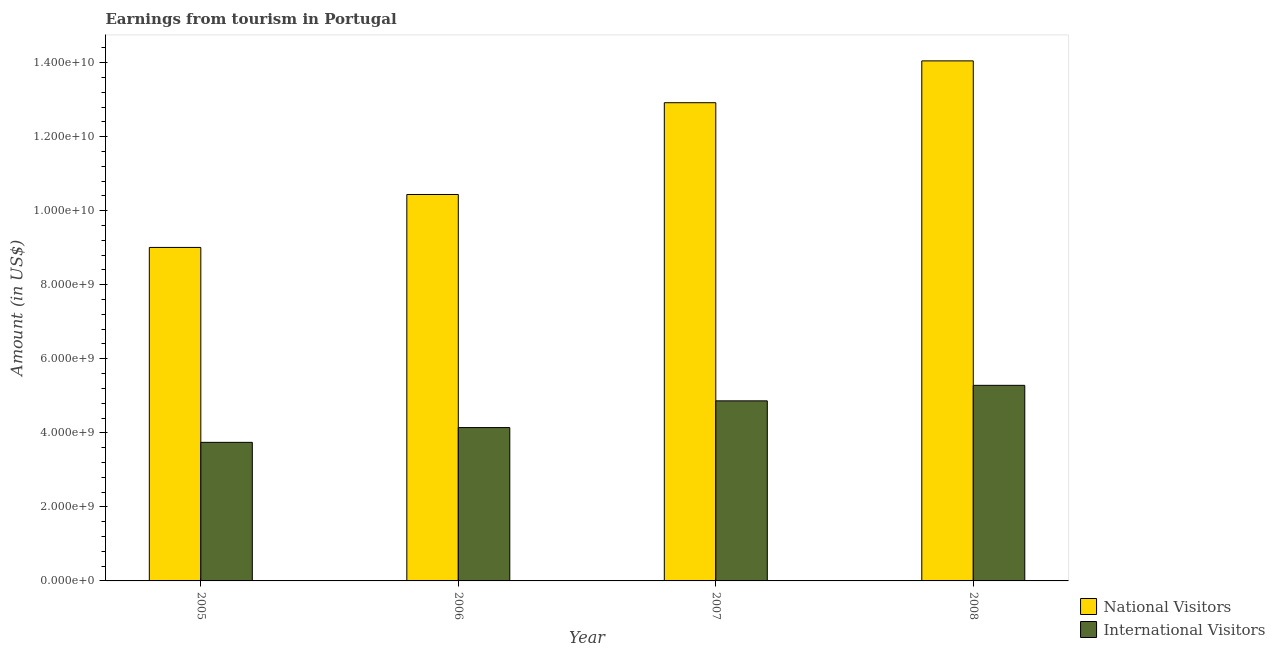How many different coloured bars are there?
Offer a terse response. 2. How many groups of bars are there?
Ensure brevity in your answer.  4. Are the number of bars on each tick of the X-axis equal?
Your answer should be compact. Yes. How many bars are there on the 4th tick from the left?
Your response must be concise. 2. How many bars are there on the 2nd tick from the right?
Make the answer very short. 2. What is the label of the 4th group of bars from the left?
Offer a terse response. 2008. What is the amount earned from national visitors in 2006?
Offer a very short reply. 1.04e+1. Across all years, what is the maximum amount earned from international visitors?
Keep it short and to the point. 5.28e+09. Across all years, what is the minimum amount earned from international visitors?
Make the answer very short. 3.74e+09. In which year was the amount earned from national visitors minimum?
Offer a terse response. 2005. What is the total amount earned from international visitors in the graph?
Your answer should be very brief. 1.80e+1. What is the difference between the amount earned from international visitors in 2006 and that in 2008?
Offer a very short reply. -1.14e+09. What is the difference between the amount earned from international visitors in 2008 and the amount earned from national visitors in 2007?
Provide a short and direct response. 4.19e+08. What is the average amount earned from national visitors per year?
Provide a short and direct response. 1.16e+1. What is the ratio of the amount earned from national visitors in 2007 to that in 2008?
Provide a succinct answer. 0.92. Is the amount earned from national visitors in 2007 less than that in 2008?
Your answer should be compact. Yes. Is the difference between the amount earned from national visitors in 2006 and 2007 greater than the difference between the amount earned from international visitors in 2006 and 2007?
Ensure brevity in your answer.  No. What is the difference between the highest and the second highest amount earned from national visitors?
Offer a terse response. 1.13e+09. What is the difference between the highest and the lowest amount earned from international visitors?
Ensure brevity in your answer.  1.54e+09. In how many years, is the amount earned from national visitors greater than the average amount earned from national visitors taken over all years?
Keep it short and to the point. 2. Is the sum of the amount earned from international visitors in 2005 and 2006 greater than the maximum amount earned from national visitors across all years?
Make the answer very short. Yes. What does the 1st bar from the left in 2007 represents?
Provide a short and direct response. National Visitors. What does the 1st bar from the right in 2008 represents?
Ensure brevity in your answer.  International Visitors. What is the difference between two consecutive major ticks on the Y-axis?
Offer a very short reply. 2.00e+09. Does the graph contain any zero values?
Ensure brevity in your answer.  No. How many legend labels are there?
Your answer should be compact. 2. What is the title of the graph?
Give a very brief answer. Earnings from tourism in Portugal. What is the label or title of the Y-axis?
Offer a terse response. Amount (in US$). What is the Amount (in US$) of National Visitors in 2005?
Provide a succinct answer. 9.01e+09. What is the Amount (in US$) of International Visitors in 2005?
Give a very brief answer. 3.74e+09. What is the Amount (in US$) in National Visitors in 2006?
Provide a short and direct response. 1.04e+1. What is the Amount (in US$) of International Visitors in 2006?
Offer a very short reply. 4.14e+09. What is the Amount (in US$) of National Visitors in 2007?
Provide a short and direct response. 1.29e+1. What is the Amount (in US$) in International Visitors in 2007?
Your answer should be very brief. 4.86e+09. What is the Amount (in US$) in National Visitors in 2008?
Your response must be concise. 1.40e+1. What is the Amount (in US$) in International Visitors in 2008?
Provide a succinct answer. 5.28e+09. Across all years, what is the maximum Amount (in US$) in National Visitors?
Offer a terse response. 1.40e+1. Across all years, what is the maximum Amount (in US$) in International Visitors?
Offer a terse response. 5.28e+09. Across all years, what is the minimum Amount (in US$) in National Visitors?
Keep it short and to the point. 9.01e+09. Across all years, what is the minimum Amount (in US$) in International Visitors?
Offer a terse response. 3.74e+09. What is the total Amount (in US$) in National Visitors in the graph?
Make the answer very short. 4.64e+1. What is the total Amount (in US$) of International Visitors in the graph?
Your response must be concise. 1.80e+1. What is the difference between the Amount (in US$) of National Visitors in 2005 and that in 2006?
Ensure brevity in your answer.  -1.43e+09. What is the difference between the Amount (in US$) of International Visitors in 2005 and that in 2006?
Keep it short and to the point. -3.99e+08. What is the difference between the Amount (in US$) in National Visitors in 2005 and that in 2007?
Keep it short and to the point. -3.91e+09. What is the difference between the Amount (in US$) in International Visitors in 2005 and that in 2007?
Offer a terse response. -1.12e+09. What is the difference between the Amount (in US$) in National Visitors in 2005 and that in 2008?
Your answer should be very brief. -5.04e+09. What is the difference between the Amount (in US$) in International Visitors in 2005 and that in 2008?
Provide a short and direct response. -1.54e+09. What is the difference between the Amount (in US$) in National Visitors in 2006 and that in 2007?
Ensure brevity in your answer.  -2.48e+09. What is the difference between the Amount (in US$) in International Visitors in 2006 and that in 2007?
Your answer should be compact. -7.22e+08. What is the difference between the Amount (in US$) of National Visitors in 2006 and that in 2008?
Offer a very short reply. -3.61e+09. What is the difference between the Amount (in US$) in International Visitors in 2006 and that in 2008?
Your answer should be very brief. -1.14e+09. What is the difference between the Amount (in US$) in National Visitors in 2007 and that in 2008?
Your answer should be very brief. -1.13e+09. What is the difference between the Amount (in US$) of International Visitors in 2007 and that in 2008?
Offer a terse response. -4.19e+08. What is the difference between the Amount (in US$) of National Visitors in 2005 and the Amount (in US$) of International Visitors in 2006?
Your answer should be compact. 4.87e+09. What is the difference between the Amount (in US$) of National Visitors in 2005 and the Amount (in US$) of International Visitors in 2007?
Ensure brevity in your answer.  4.14e+09. What is the difference between the Amount (in US$) of National Visitors in 2005 and the Amount (in US$) of International Visitors in 2008?
Ensure brevity in your answer.  3.72e+09. What is the difference between the Amount (in US$) in National Visitors in 2006 and the Amount (in US$) in International Visitors in 2007?
Make the answer very short. 5.57e+09. What is the difference between the Amount (in US$) of National Visitors in 2006 and the Amount (in US$) of International Visitors in 2008?
Provide a short and direct response. 5.16e+09. What is the difference between the Amount (in US$) in National Visitors in 2007 and the Amount (in US$) in International Visitors in 2008?
Offer a terse response. 7.63e+09. What is the average Amount (in US$) of National Visitors per year?
Your response must be concise. 1.16e+1. What is the average Amount (in US$) in International Visitors per year?
Offer a terse response. 4.51e+09. In the year 2005, what is the difference between the Amount (in US$) of National Visitors and Amount (in US$) of International Visitors?
Give a very brief answer. 5.26e+09. In the year 2006, what is the difference between the Amount (in US$) of National Visitors and Amount (in US$) of International Visitors?
Make the answer very short. 6.30e+09. In the year 2007, what is the difference between the Amount (in US$) of National Visitors and Amount (in US$) of International Visitors?
Offer a terse response. 8.05e+09. In the year 2008, what is the difference between the Amount (in US$) of National Visitors and Amount (in US$) of International Visitors?
Make the answer very short. 8.76e+09. What is the ratio of the Amount (in US$) of National Visitors in 2005 to that in 2006?
Offer a terse response. 0.86. What is the ratio of the Amount (in US$) of International Visitors in 2005 to that in 2006?
Make the answer very short. 0.9. What is the ratio of the Amount (in US$) in National Visitors in 2005 to that in 2007?
Give a very brief answer. 0.7. What is the ratio of the Amount (in US$) of International Visitors in 2005 to that in 2007?
Keep it short and to the point. 0.77. What is the ratio of the Amount (in US$) in National Visitors in 2005 to that in 2008?
Keep it short and to the point. 0.64. What is the ratio of the Amount (in US$) in International Visitors in 2005 to that in 2008?
Give a very brief answer. 0.71. What is the ratio of the Amount (in US$) in National Visitors in 2006 to that in 2007?
Provide a short and direct response. 0.81. What is the ratio of the Amount (in US$) of International Visitors in 2006 to that in 2007?
Provide a short and direct response. 0.85. What is the ratio of the Amount (in US$) of National Visitors in 2006 to that in 2008?
Your response must be concise. 0.74. What is the ratio of the Amount (in US$) in International Visitors in 2006 to that in 2008?
Your answer should be compact. 0.78. What is the ratio of the Amount (in US$) of National Visitors in 2007 to that in 2008?
Your response must be concise. 0.92. What is the ratio of the Amount (in US$) in International Visitors in 2007 to that in 2008?
Give a very brief answer. 0.92. What is the difference between the highest and the second highest Amount (in US$) of National Visitors?
Your answer should be compact. 1.13e+09. What is the difference between the highest and the second highest Amount (in US$) in International Visitors?
Your answer should be very brief. 4.19e+08. What is the difference between the highest and the lowest Amount (in US$) in National Visitors?
Your answer should be very brief. 5.04e+09. What is the difference between the highest and the lowest Amount (in US$) in International Visitors?
Offer a very short reply. 1.54e+09. 